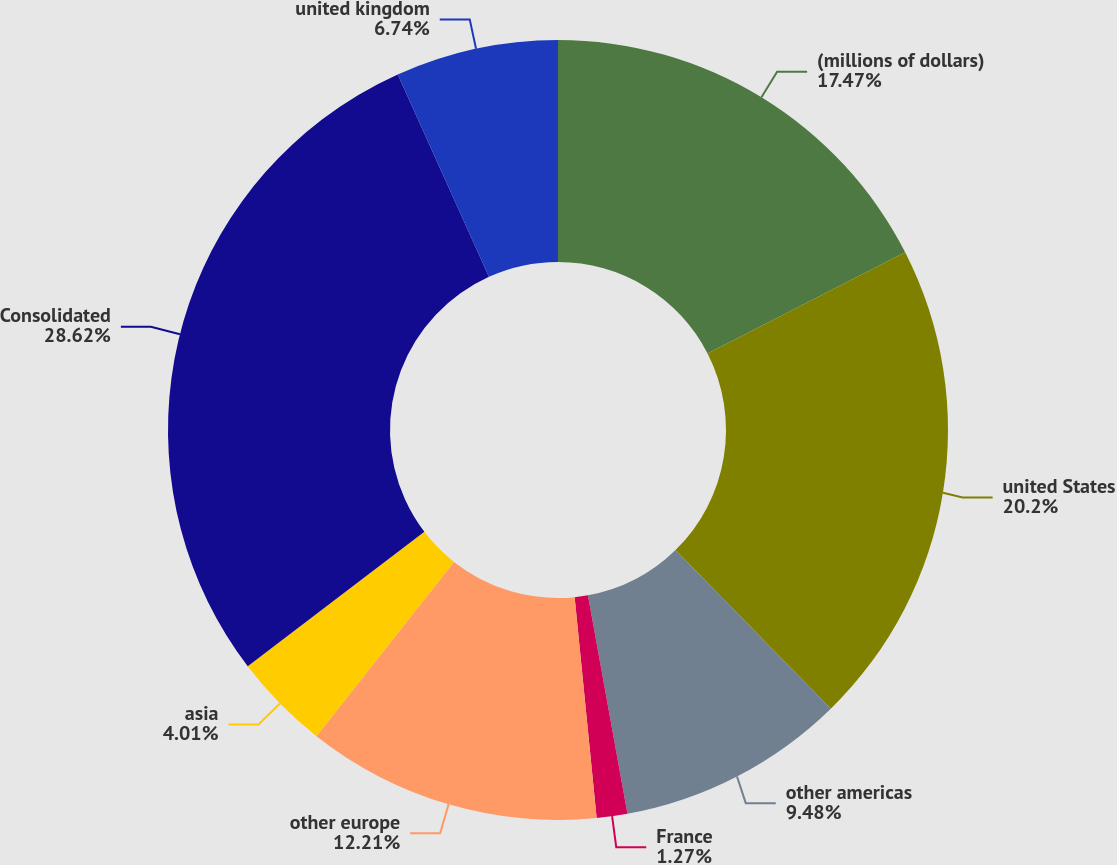Convert chart to OTSL. <chart><loc_0><loc_0><loc_500><loc_500><pie_chart><fcel>(millions of dollars)<fcel>united States<fcel>other americas<fcel>France<fcel>other europe<fcel>asia<fcel>Consolidated<fcel>united kingdom<nl><fcel>17.47%<fcel>20.2%<fcel>9.48%<fcel>1.27%<fcel>12.21%<fcel>4.01%<fcel>28.62%<fcel>6.74%<nl></chart> 